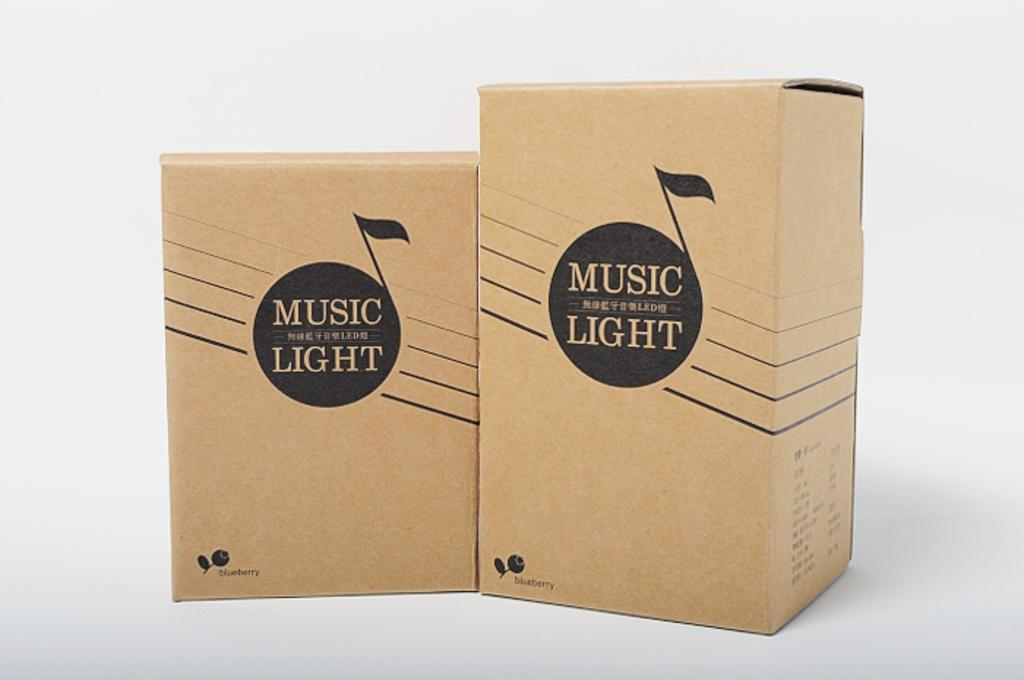<image>
Render a clear and concise summary of the photo. two boxes standing next to each other that are both labeled 'music light' 